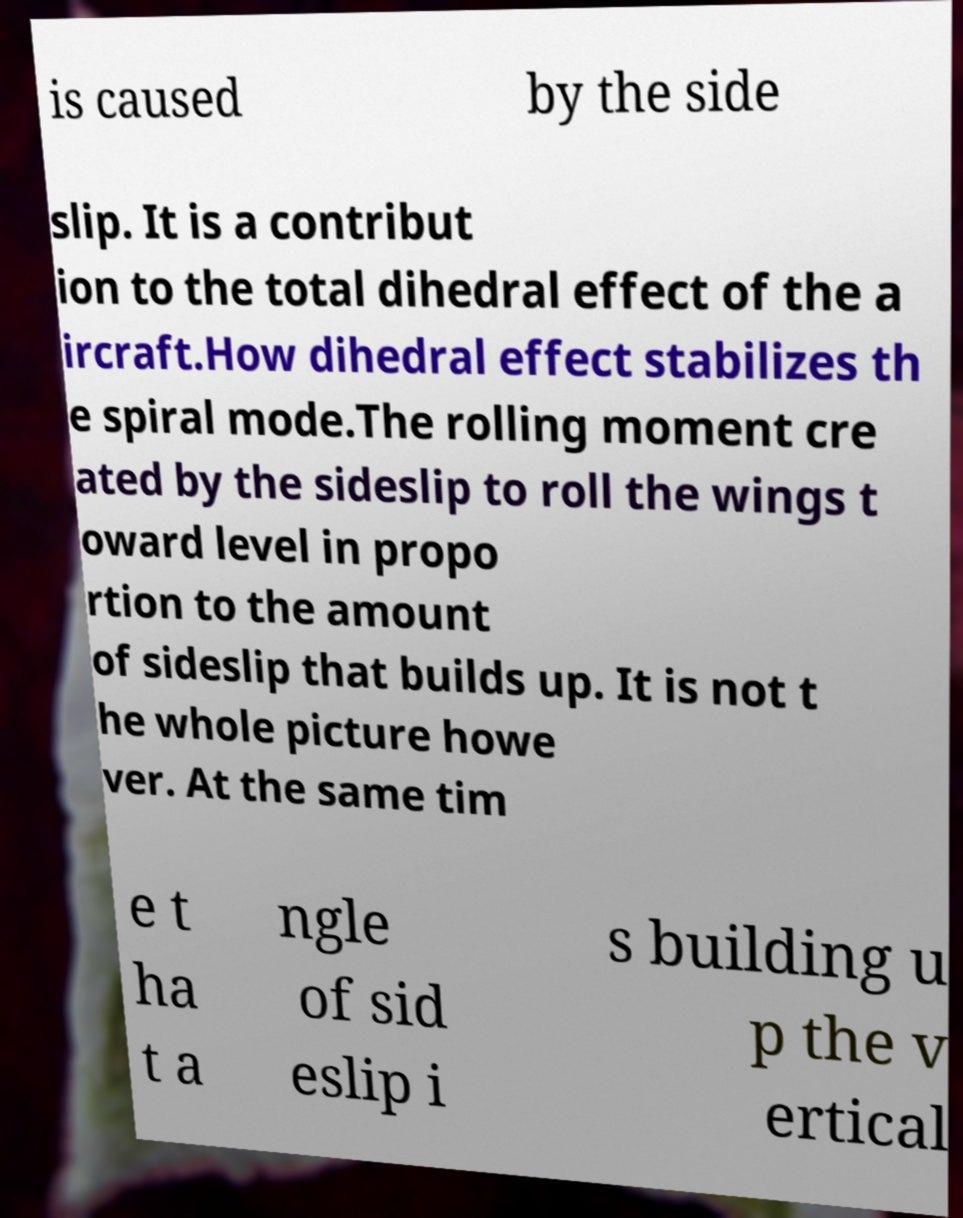Can you read and provide the text displayed in the image?This photo seems to have some interesting text. Can you extract and type it out for me? is caused by the side slip. It is a contribut ion to the total dihedral effect of the a ircraft.How dihedral effect stabilizes th e spiral mode.The rolling moment cre ated by the sideslip to roll the wings t oward level in propo rtion to the amount of sideslip that builds up. It is not t he whole picture howe ver. At the same tim e t ha t a ngle of sid eslip i s building u p the v ertical 